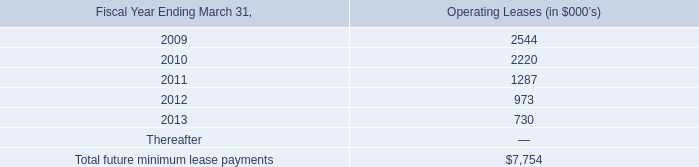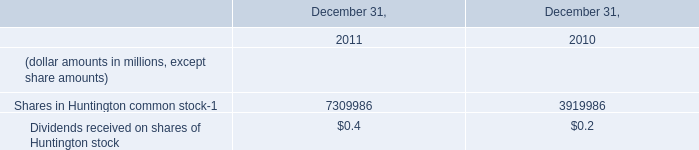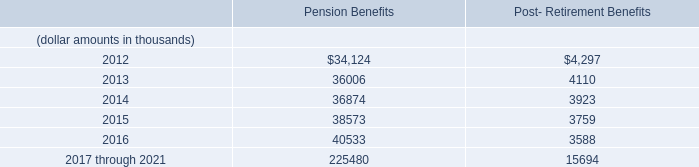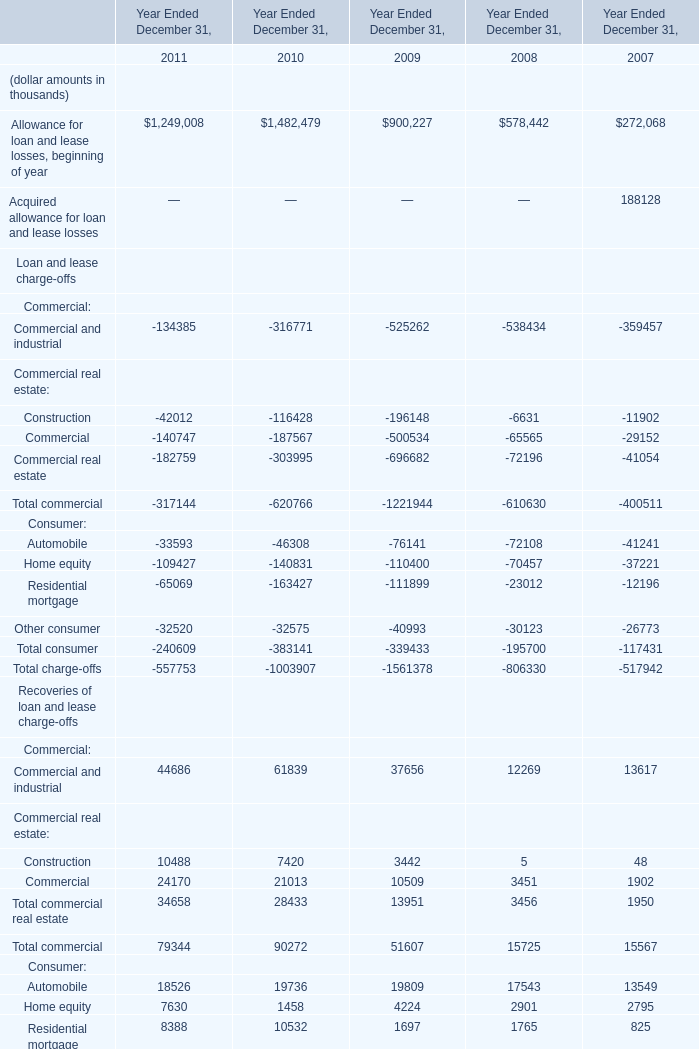the total rent for leases in the fiscal years ended march 31 , 2008 , 2007 and 2006 is what percent of the entire future minimum lease payments? 
Computations: (((2.2 + 1.6) + 1.3) / (7754 / 1000))
Answer: 0.65773. 